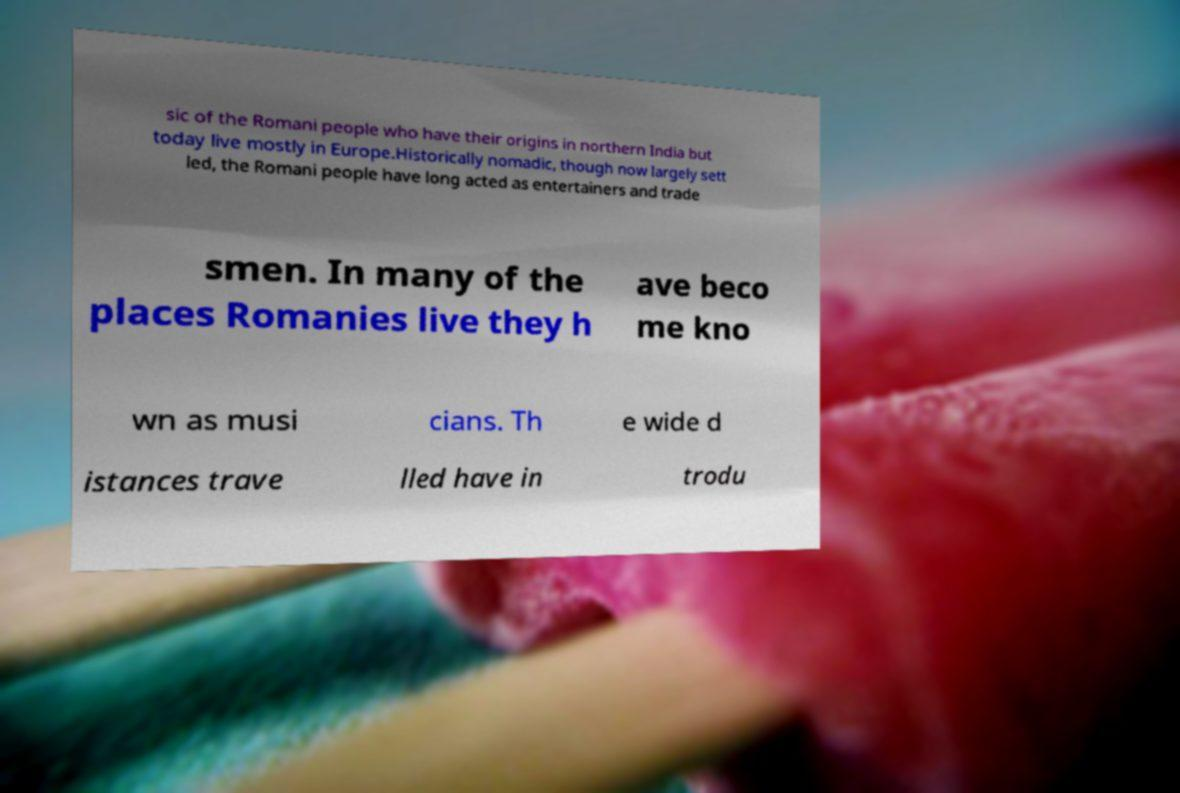For documentation purposes, I need the text within this image transcribed. Could you provide that? sic of the Romani people who have their origins in northern India but today live mostly in Europe.Historically nomadic, though now largely sett led, the Romani people have long acted as entertainers and trade smen. In many of the places Romanies live they h ave beco me kno wn as musi cians. Th e wide d istances trave lled have in trodu 